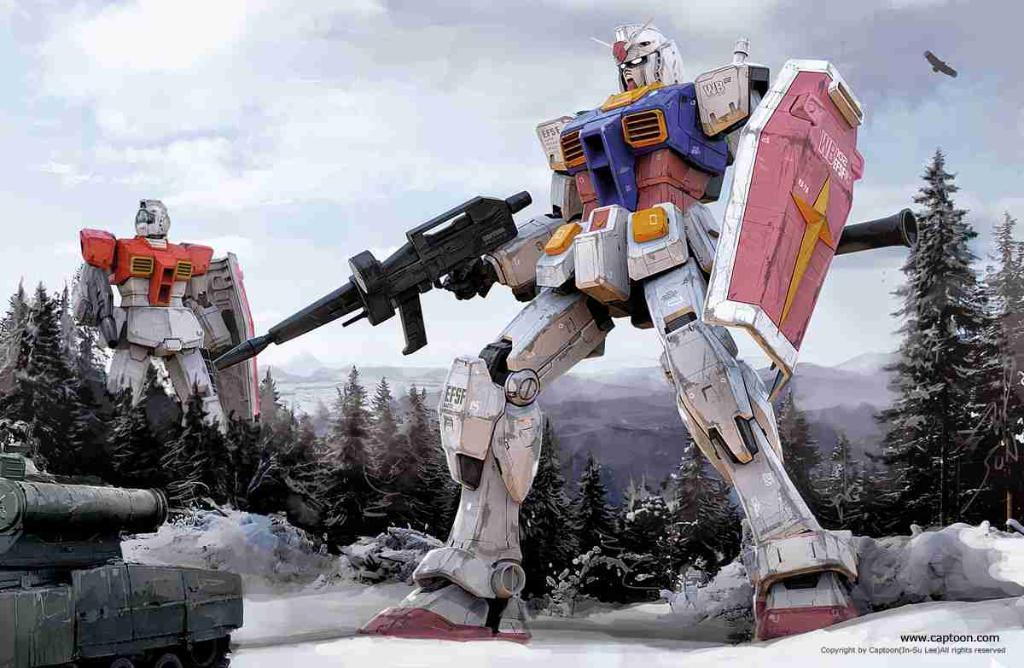What type of objects are featured in the image? There are two robotic toys in the image. Where is the tank located in the image? The tank is in the bottom left of the image. What can be seen behind the tank? Trees are present behind the tank. What is the condition of the sky in the image? The sky is covered with clouds. What type of scent can be detected from the robotic toys in the image? There is no indication of a scent associated with the robotic toys in the image. Is there a plane visible in the image? No, there is no plane present in the image. 